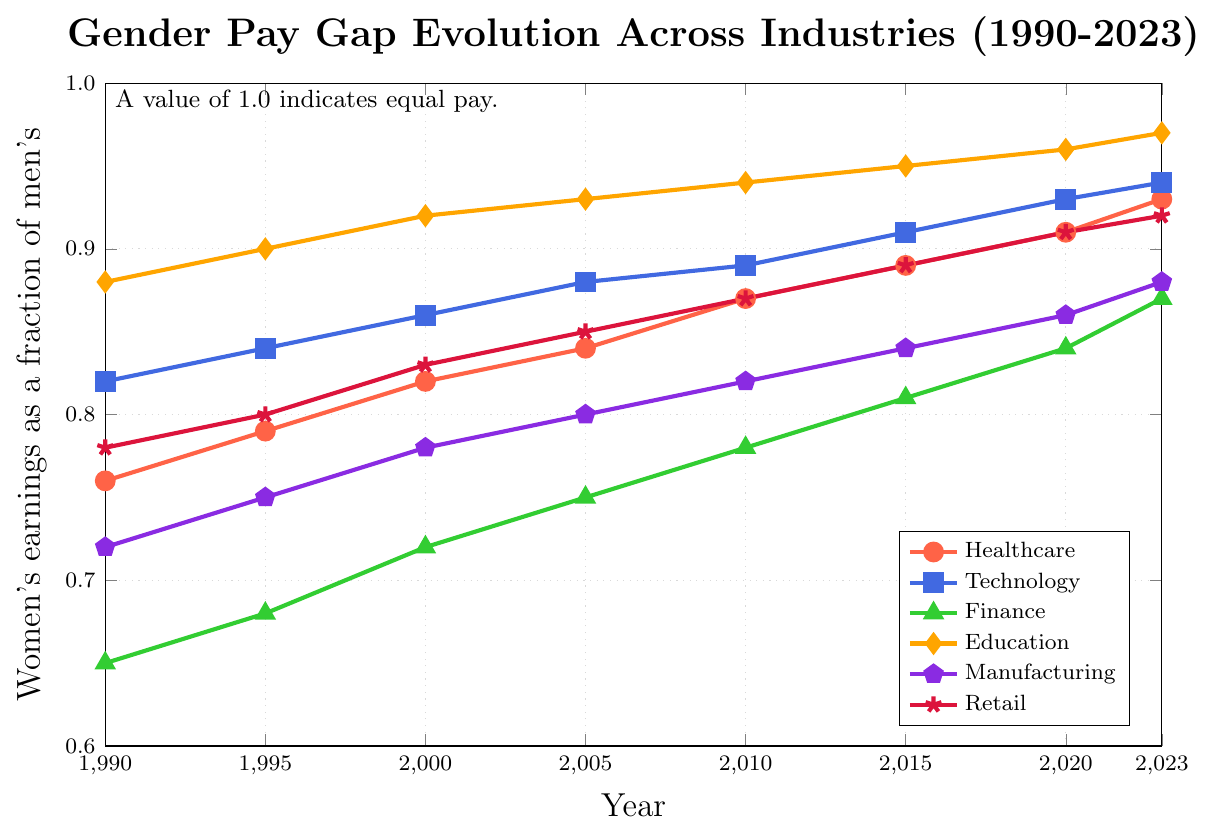What industry had the largest gender pay gap in 1990? The figure shows different lines representing various industries. By looking at the 1990 data points, the line for Finance is the lowest on the y-axis, which corresponds to the smallest value in 1990, indicating the largest gender pay gap.
Answer: Finance Which industry achieved the highest gender pay equality by 2023? Referring to the 2023 data points, the Education line is closest to the value of 1.0 on the y-axis, suggesting that the Education industry has achieved the highest level of gender pay equality.
Answer: Education Between which years did Technology see the greatest increase in gender pay equality? To find this, examine the slope of the Technology line. The steepest slope indicates the greatest increase. From 1990 to 1995, the increase is from 0.82 to 0.84; from 1995 to 2000, it is from 0.84 to 0.86. These are consistent incremental increases, but between 2015 and 2020, the increase is from 0.91 to 0.93, which is a greater jump compared to earlier periods.
Answer: 2015 to 2020 What is the overall trend in gender pay equality in Retail from 1990 to 2023? The Retail line shows a consistent upward trend from 1990 to 2023, indicating a steady improvement in gender pay equality over the years.
Answer: Upward trend Compare the gender pay gap in Manufacturing and Finance in 2005. For 2005, observe the y-axis values of the Manufacturing and Finance lines. Manufacturing is at 0.80 and Finance is at 0.75. Thus, in 2005, the gender pay gap was smaller in Manufacturing than in Finance.
Answer: Smaller in Manufacturing What is the average gender pay ratio in Healthcare over the entire period from 1990 to 2023? To find the average: (0.76 + 0.79 + 0.82 + 0.84 + 0.87 + 0.89 + 0.91 + 0.93) / 8 = 0.85125.
Answer: 0.85 Which industry showed the least improvement in gender pay equality from 1990 to 2000? Compare the slopes of all lines between 1990 and 2000. The Finance industry had an increase from 0.65 to 0.72, which shows the smallest improvement over this period.
Answer: Finance 